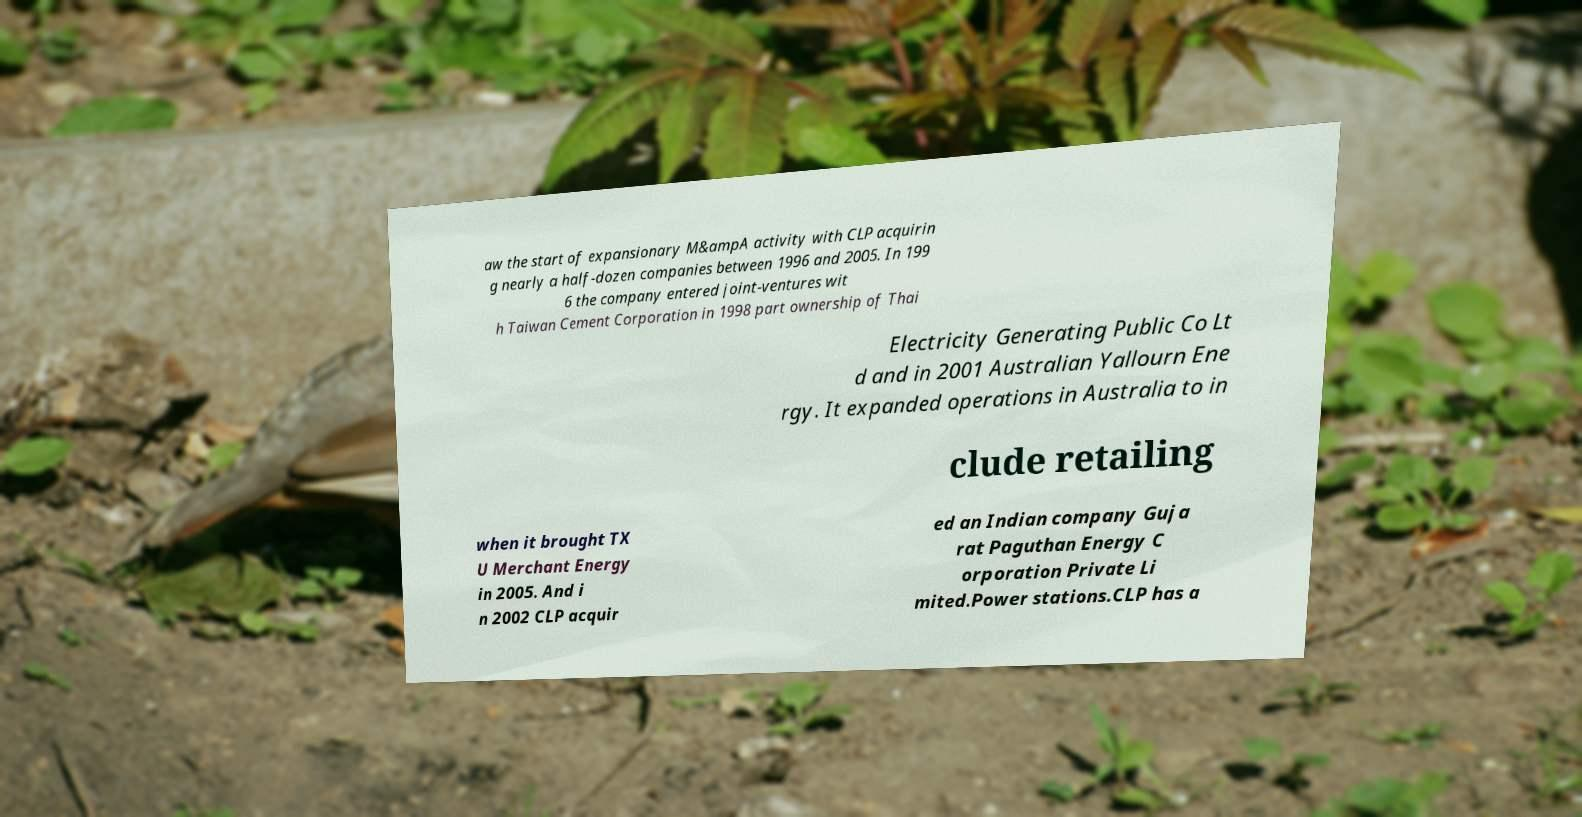Could you assist in decoding the text presented in this image and type it out clearly? aw the start of expansionary M&ampA activity with CLP acquirin g nearly a half-dozen companies between 1996 and 2005. In 199 6 the company entered joint-ventures wit h Taiwan Cement Corporation in 1998 part ownership of Thai Electricity Generating Public Co Lt d and in 2001 Australian Yallourn Ene rgy. It expanded operations in Australia to in clude retailing when it brought TX U Merchant Energy in 2005. And i n 2002 CLP acquir ed an Indian company Guja rat Paguthan Energy C orporation Private Li mited.Power stations.CLP has a 